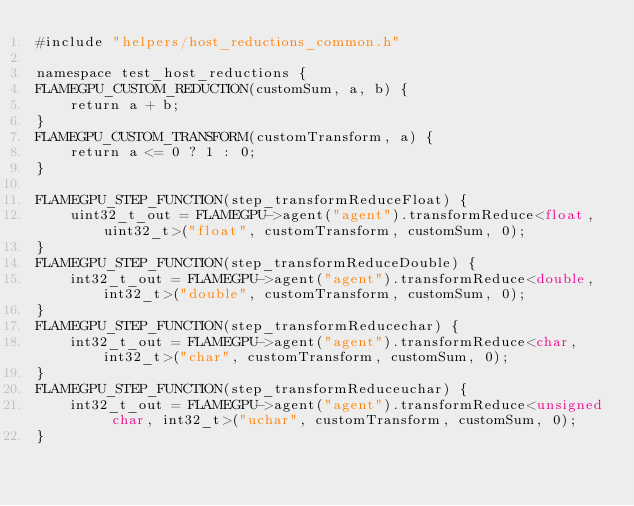Convert code to text. <code><loc_0><loc_0><loc_500><loc_500><_Cuda_>#include "helpers/host_reductions_common.h"

namespace test_host_reductions {
FLAMEGPU_CUSTOM_REDUCTION(customSum, a, b) {
    return a + b;
}
FLAMEGPU_CUSTOM_TRANSFORM(customTransform, a) {
    return a <= 0 ? 1 : 0;
}

FLAMEGPU_STEP_FUNCTION(step_transformReduceFloat) {
    uint32_t_out = FLAMEGPU->agent("agent").transformReduce<float, uint32_t>("float", customTransform, customSum, 0);
}
FLAMEGPU_STEP_FUNCTION(step_transformReduceDouble) {
    int32_t_out = FLAMEGPU->agent("agent").transformReduce<double, int32_t>("double", customTransform, customSum, 0);
}
FLAMEGPU_STEP_FUNCTION(step_transformReducechar) {
    int32_t_out = FLAMEGPU->agent("agent").transformReduce<char, int32_t>("char", customTransform, customSum, 0);
}
FLAMEGPU_STEP_FUNCTION(step_transformReduceuchar) {
    int32_t_out = FLAMEGPU->agent("agent").transformReduce<unsigned char, int32_t>("uchar", customTransform, customSum, 0);
}</code> 